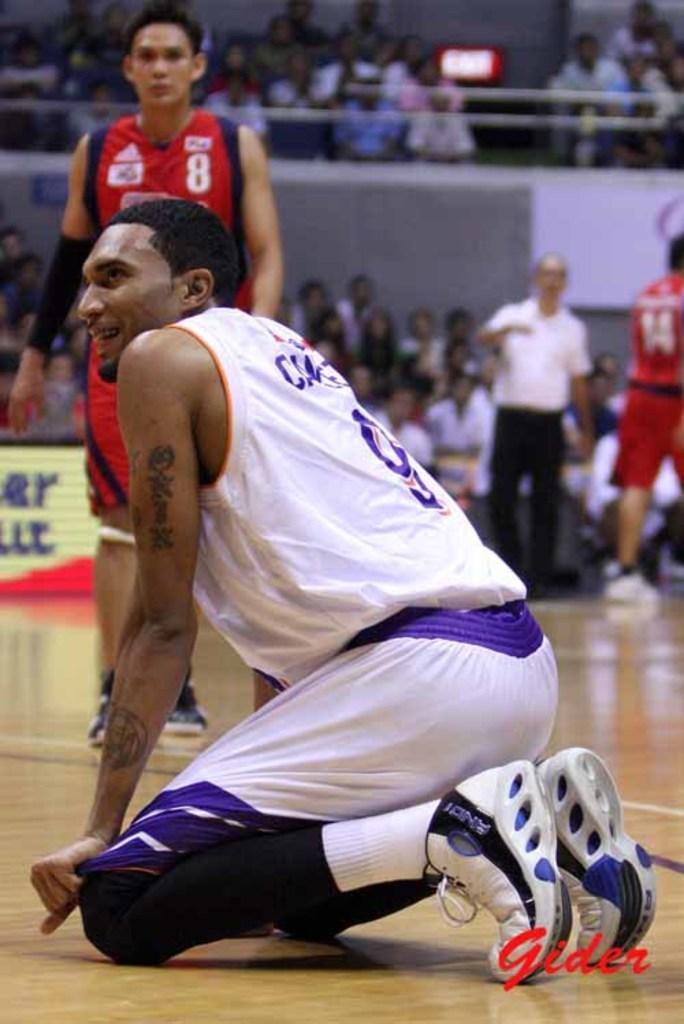Please provide a concise description of this image. In this image we can see a person sitting on his knees on the floor. We can also see some people standing on the floor. On the backside we can see a group of people sitting beside a fence, a clock on a wall and a signboard. On the bottom of the image we can see some text. 